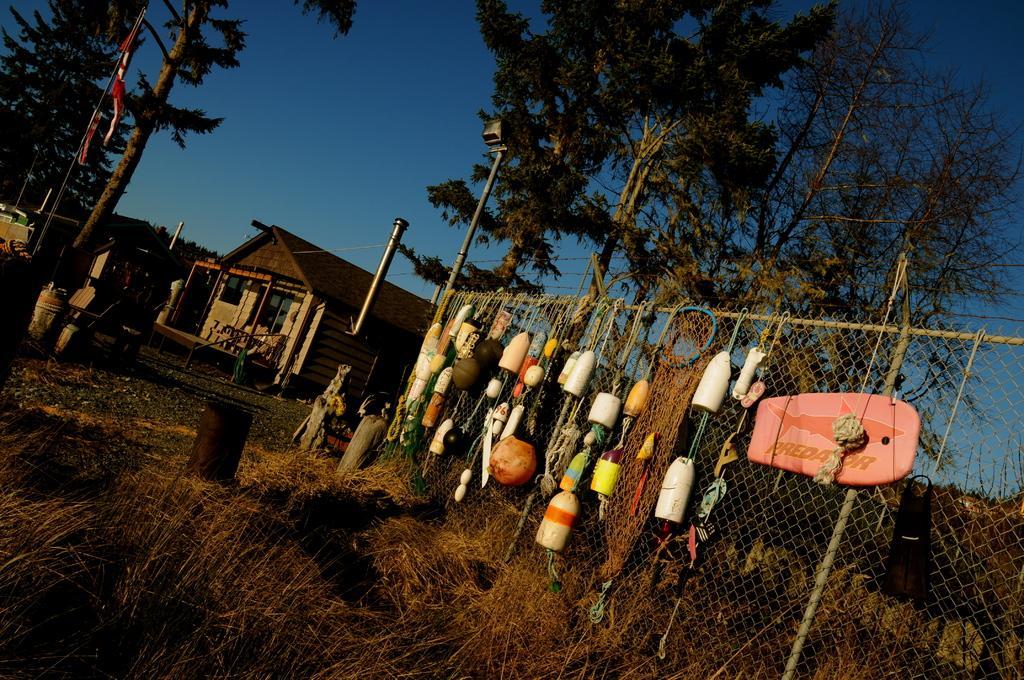Could you give a brief overview of what you see in this image? In this image there is a grass at bottom of this image and there is a fencing wall at right side to this image and there are some objects are hanging to this fencing wall, and there are some trees in the background , There are some trees at left side as well and there is a house in middle of this image and there is a sky at top of this image. 